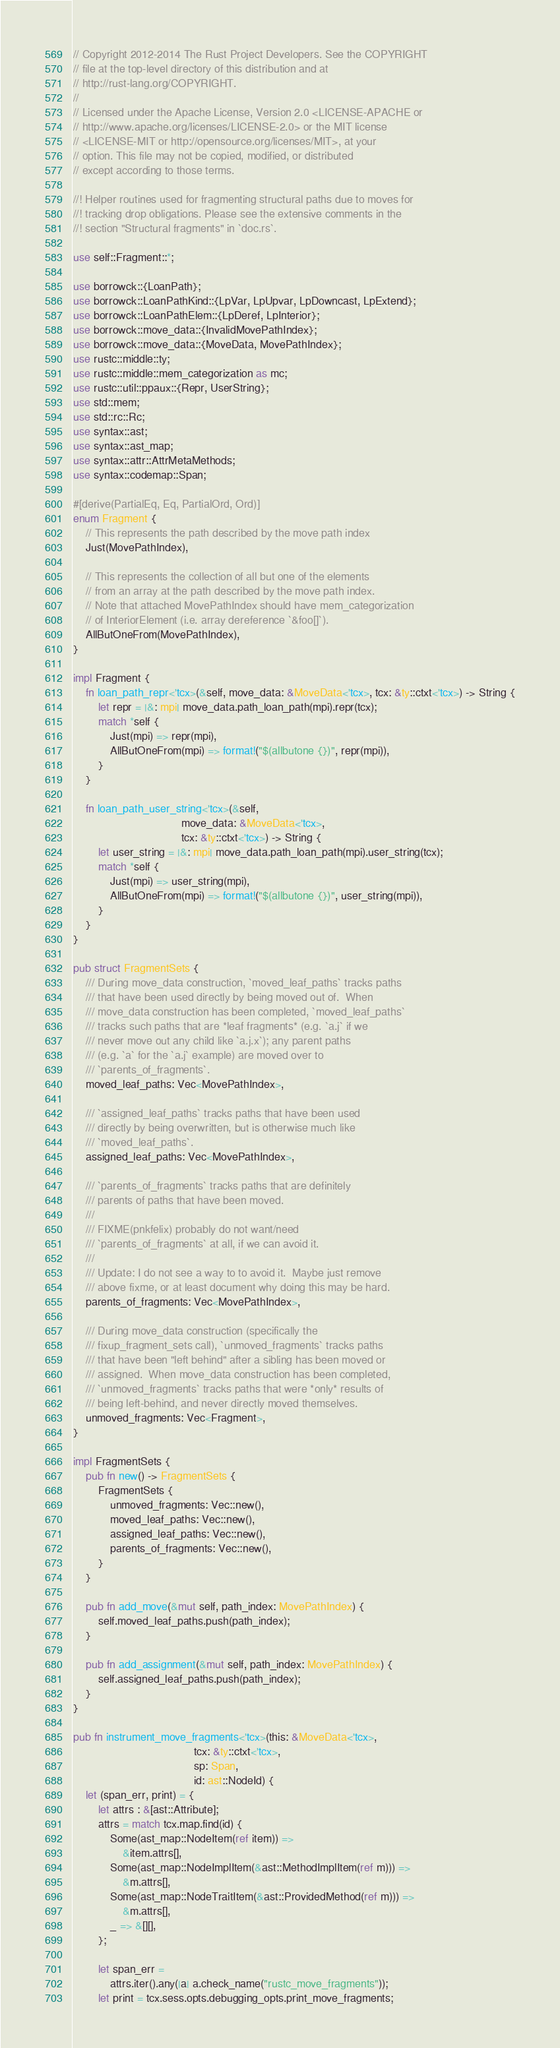<code> <loc_0><loc_0><loc_500><loc_500><_Rust_>// Copyright 2012-2014 The Rust Project Developers. See the COPYRIGHT
// file at the top-level directory of this distribution and at
// http://rust-lang.org/COPYRIGHT.
//
// Licensed under the Apache License, Version 2.0 <LICENSE-APACHE or
// http://www.apache.org/licenses/LICENSE-2.0> or the MIT license
// <LICENSE-MIT or http://opensource.org/licenses/MIT>, at your
// option. This file may not be copied, modified, or distributed
// except according to those terms.

//! Helper routines used for fragmenting structural paths due to moves for
//! tracking drop obligations. Please see the extensive comments in the
//! section "Structural fragments" in `doc.rs`.

use self::Fragment::*;

use borrowck::{LoanPath};
use borrowck::LoanPathKind::{LpVar, LpUpvar, LpDowncast, LpExtend};
use borrowck::LoanPathElem::{LpDeref, LpInterior};
use borrowck::move_data::{InvalidMovePathIndex};
use borrowck::move_data::{MoveData, MovePathIndex};
use rustc::middle::ty;
use rustc::middle::mem_categorization as mc;
use rustc::util::ppaux::{Repr, UserString};
use std::mem;
use std::rc::Rc;
use syntax::ast;
use syntax::ast_map;
use syntax::attr::AttrMetaMethods;
use syntax::codemap::Span;

#[derive(PartialEq, Eq, PartialOrd, Ord)]
enum Fragment {
    // This represents the path described by the move path index
    Just(MovePathIndex),

    // This represents the collection of all but one of the elements
    // from an array at the path described by the move path index.
    // Note that attached MovePathIndex should have mem_categorization
    // of InteriorElement (i.e. array dereference `&foo[]`).
    AllButOneFrom(MovePathIndex),
}

impl Fragment {
    fn loan_path_repr<'tcx>(&self, move_data: &MoveData<'tcx>, tcx: &ty::ctxt<'tcx>) -> String {
        let repr = |&: mpi| move_data.path_loan_path(mpi).repr(tcx);
        match *self {
            Just(mpi) => repr(mpi),
            AllButOneFrom(mpi) => format!("$(allbutone {})", repr(mpi)),
        }
    }

    fn loan_path_user_string<'tcx>(&self,
                                   move_data: &MoveData<'tcx>,
                                   tcx: &ty::ctxt<'tcx>) -> String {
        let user_string = |&: mpi| move_data.path_loan_path(mpi).user_string(tcx);
        match *self {
            Just(mpi) => user_string(mpi),
            AllButOneFrom(mpi) => format!("$(allbutone {})", user_string(mpi)),
        }
    }
}

pub struct FragmentSets {
    /// During move_data construction, `moved_leaf_paths` tracks paths
    /// that have been used directly by being moved out of.  When
    /// move_data construction has been completed, `moved_leaf_paths`
    /// tracks such paths that are *leaf fragments* (e.g. `a.j` if we
    /// never move out any child like `a.j.x`); any parent paths
    /// (e.g. `a` for the `a.j` example) are moved over to
    /// `parents_of_fragments`.
    moved_leaf_paths: Vec<MovePathIndex>,

    /// `assigned_leaf_paths` tracks paths that have been used
    /// directly by being overwritten, but is otherwise much like
    /// `moved_leaf_paths`.
    assigned_leaf_paths: Vec<MovePathIndex>,

    /// `parents_of_fragments` tracks paths that are definitely
    /// parents of paths that have been moved.
    ///
    /// FIXME(pnkfelix) probably do not want/need
    /// `parents_of_fragments` at all, if we can avoid it.
    ///
    /// Update: I do not see a way to to avoid it.  Maybe just remove
    /// above fixme, or at least document why doing this may be hard.
    parents_of_fragments: Vec<MovePathIndex>,

    /// During move_data construction (specifically the
    /// fixup_fragment_sets call), `unmoved_fragments` tracks paths
    /// that have been "left behind" after a sibling has been moved or
    /// assigned.  When move_data construction has been completed,
    /// `unmoved_fragments` tracks paths that were *only* results of
    /// being left-behind, and never directly moved themselves.
    unmoved_fragments: Vec<Fragment>,
}

impl FragmentSets {
    pub fn new() -> FragmentSets {
        FragmentSets {
            unmoved_fragments: Vec::new(),
            moved_leaf_paths: Vec::new(),
            assigned_leaf_paths: Vec::new(),
            parents_of_fragments: Vec::new(),
        }
    }

    pub fn add_move(&mut self, path_index: MovePathIndex) {
        self.moved_leaf_paths.push(path_index);
    }

    pub fn add_assignment(&mut self, path_index: MovePathIndex) {
        self.assigned_leaf_paths.push(path_index);
    }
}

pub fn instrument_move_fragments<'tcx>(this: &MoveData<'tcx>,
                                       tcx: &ty::ctxt<'tcx>,
                                       sp: Span,
                                       id: ast::NodeId) {
    let (span_err, print) = {
        let attrs : &[ast::Attribute];
        attrs = match tcx.map.find(id) {
            Some(ast_map::NodeItem(ref item)) =>
                &item.attrs[],
            Some(ast_map::NodeImplItem(&ast::MethodImplItem(ref m))) =>
                &m.attrs[],
            Some(ast_map::NodeTraitItem(&ast::ProvidedMethod(ref m))) =>
                &m.attrs[],
            _ => &[][],
        };

        let span_err =
            attrs.iter().any(|a| a.check_name("rustc_move_fragments"));
        let print = tcx.sess.opts.debugging_opts.print_move_fragments;
</code> 